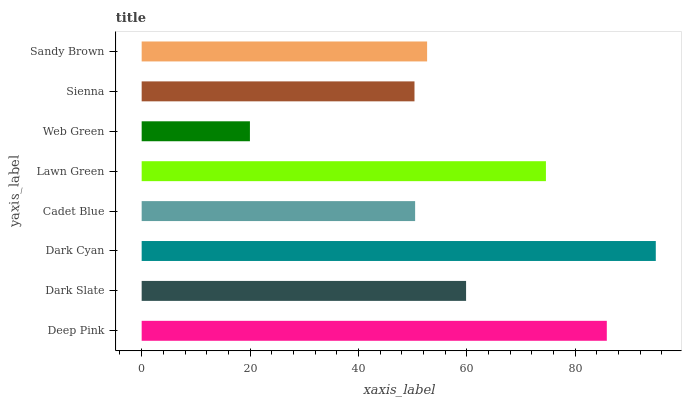Is Web Green the minimum?
Answer yes or no. Yes. Is Dark Cyan the maximum?
Answer yes or no. Yes. Is Dark Slate the minimum?
Answer yes or no. No. Is Dark Slate the maximum?
Answer yes or no. No. Is Deep Pink greater than Dark Slate?
Answer yes or no. Yes. Is Dark Slate less than Deep Pink?
Answer yes or no. Yes. Is Dark Slate greater than Deep Pink?
Answer yes or no. No. Is Deep Pink less than Dark Slate?
Answer yes or no. No. Is Dark Slate the high median?
Answer yes or no. Yes. Is Sandy Brown the low median?
Answer yes or no. Yes. Is Deep Pink the high median?
Answer yes or no. No. Is Lawn Green the low median?
Answer yes or no. No. 